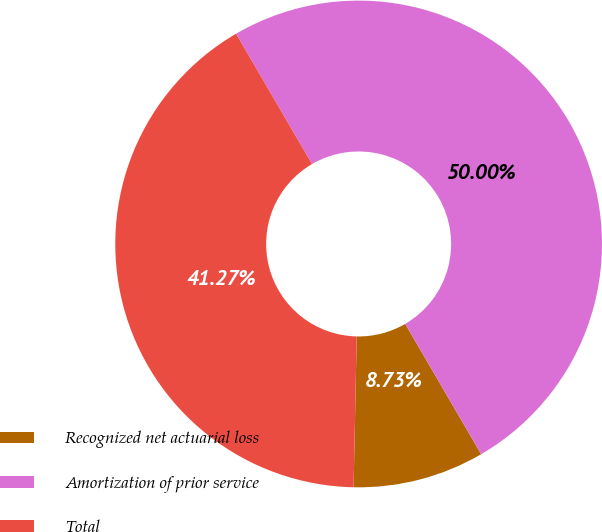Convert chart to OTSL. <chart><loc_0><loc_0><loc_500><loc_500><pie_chart><fcel>Recognized net actuarial loss<fcel>Amortization of prior service<fcel>Total<nl><fcel>8.73%<fcel>50.0%<fcel>41.27%<nl></chart> 